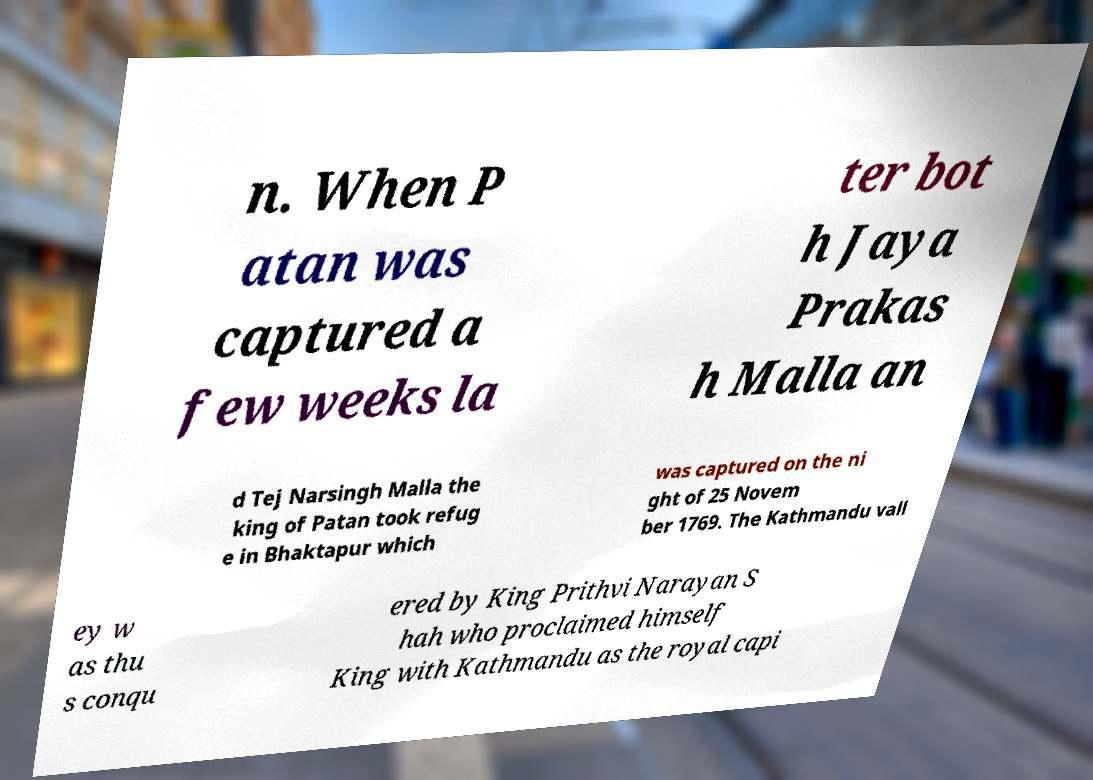There's text embedded in this image that I need extracted. Can you transcribe it verbatim? n. When P atan was captured a few weeks la ter bot h Jaya Prakas h Malla an d Tej Narsingh Malla the king of Patan took refug e in Bhaktapur which was captured on the ni ght of 25 Novem ber 1769. The Kathmandu vall ey w as thu s conqu ered by King Prithvi Narayan S hah who proclaimed himself King with Kathmandu as the royal capi 